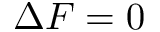<formula> <loc_0><loc_0><loc_500><loc_500>\Delta F = 0</formula> 